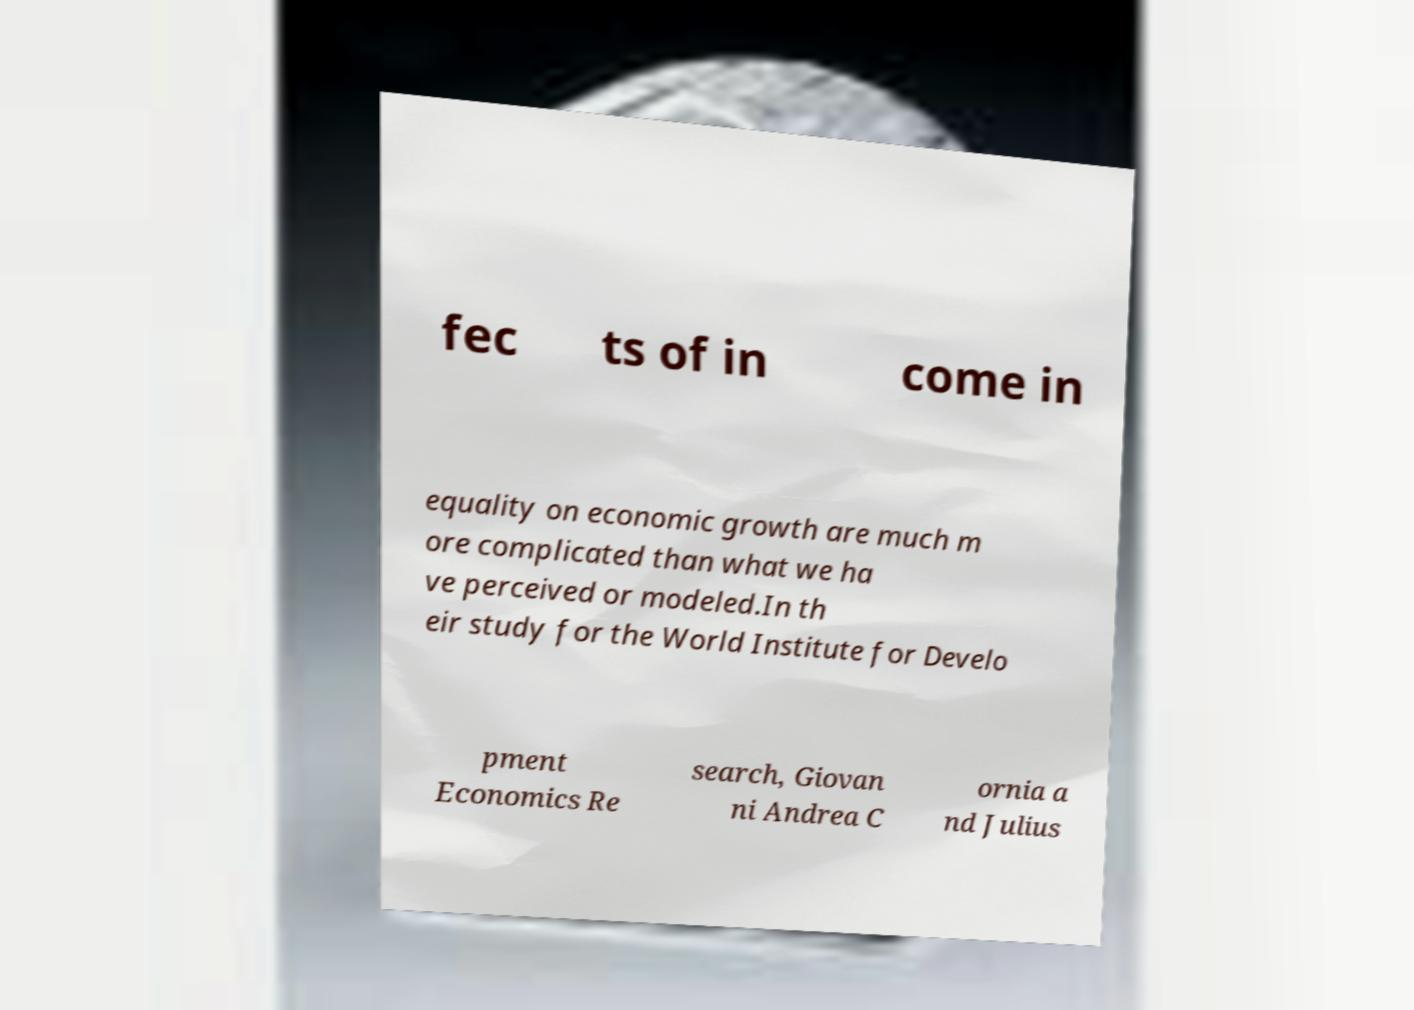Can you read and provide the text displayed in the image?This photo seems to have some interesting text. Can you extract and type it out for me? fec ts of in come in equality on economic growth are much m ore complicated than what we ha ve perceived or modeled.In th eir study for the World Institute for Develo pment Economics Re search, Giovan ni Andrea C ornia a nd Julius 